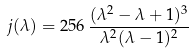Convert formula to latex. <formula><loc_0><loc_0><loc_500><loc_500>j ( \lambda ) = 2 5 6 \, \frac { ( \lambda ^ { 2 } - \lambda + 1 ) ^ { 3 } } { \lambda ^ { 2 } ( \lambda - 1 ) ^ { 2 } }</formula> 